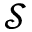Convert formula to latex. <formula><loc_0><loc_0><loc_500><loc_500>\mathcal { S }</formula> 